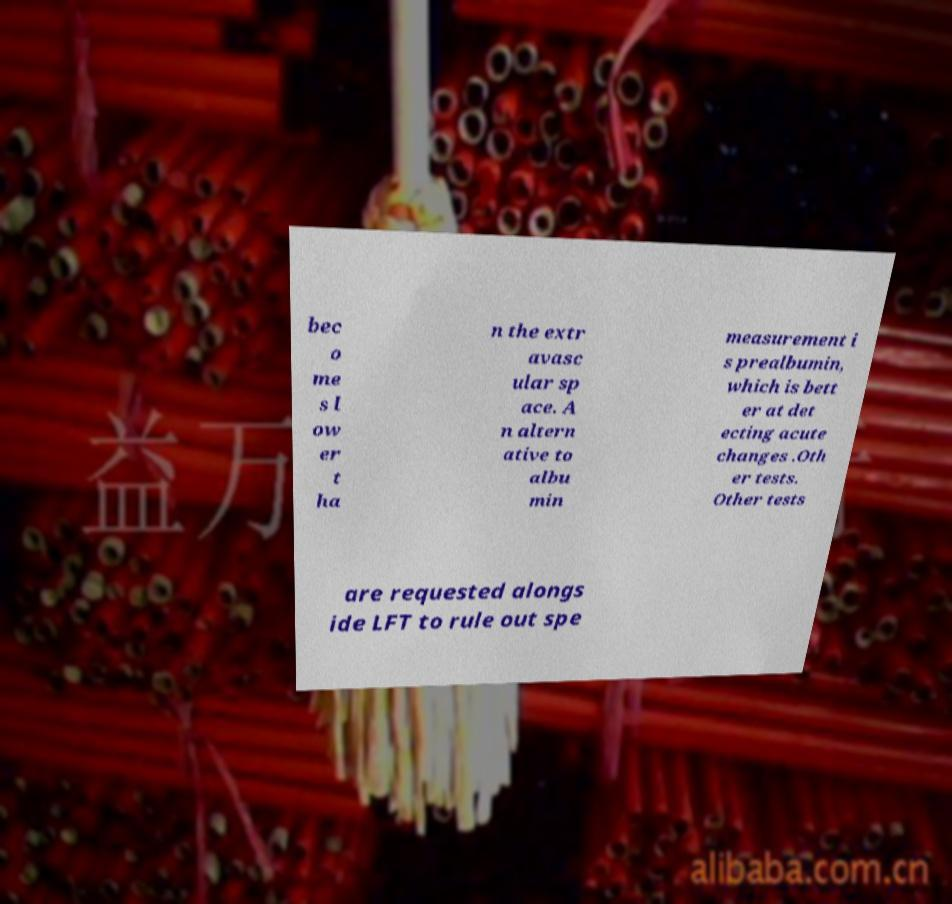For documentation purposes, I need the text within this image transcribed. Could you provide that? bec o me s l ow er t ha n the extr avasc ular sp ace. A n altern ative to albu min measurement i s prealbumin, which is bett er at det ecting acute changes .Oth er tests. Other tests are requested alongs ide LFT to rule out spe 